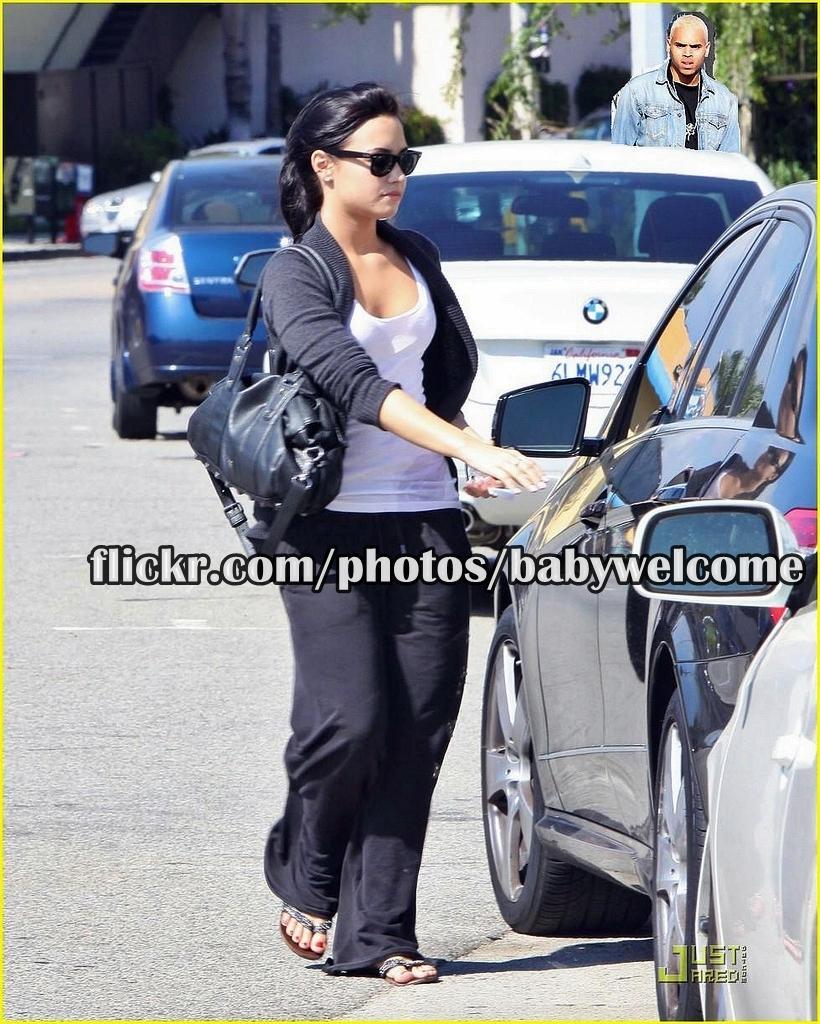Could you give a brief overview of what you see in this image? This is an edited image, in this image there are cars on a road and people are standing on a road, in the middle there is some text, on the bottom right there is some text. 